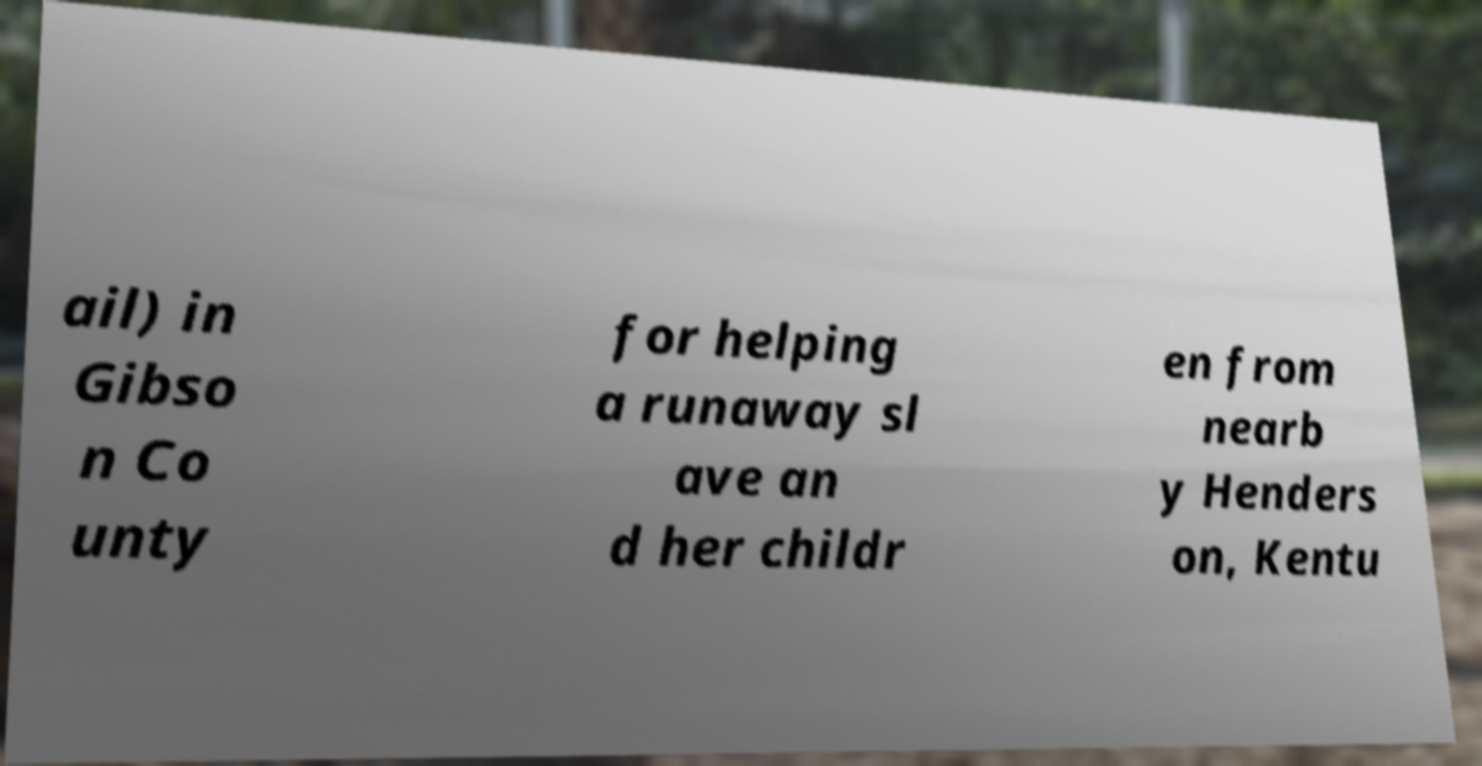I need the written content from this picture converted into text. Can you do that? ail) in Gibso n Co unty for helping a runaway sl ave an d her childr en from nearb y Henders on, Kentu 